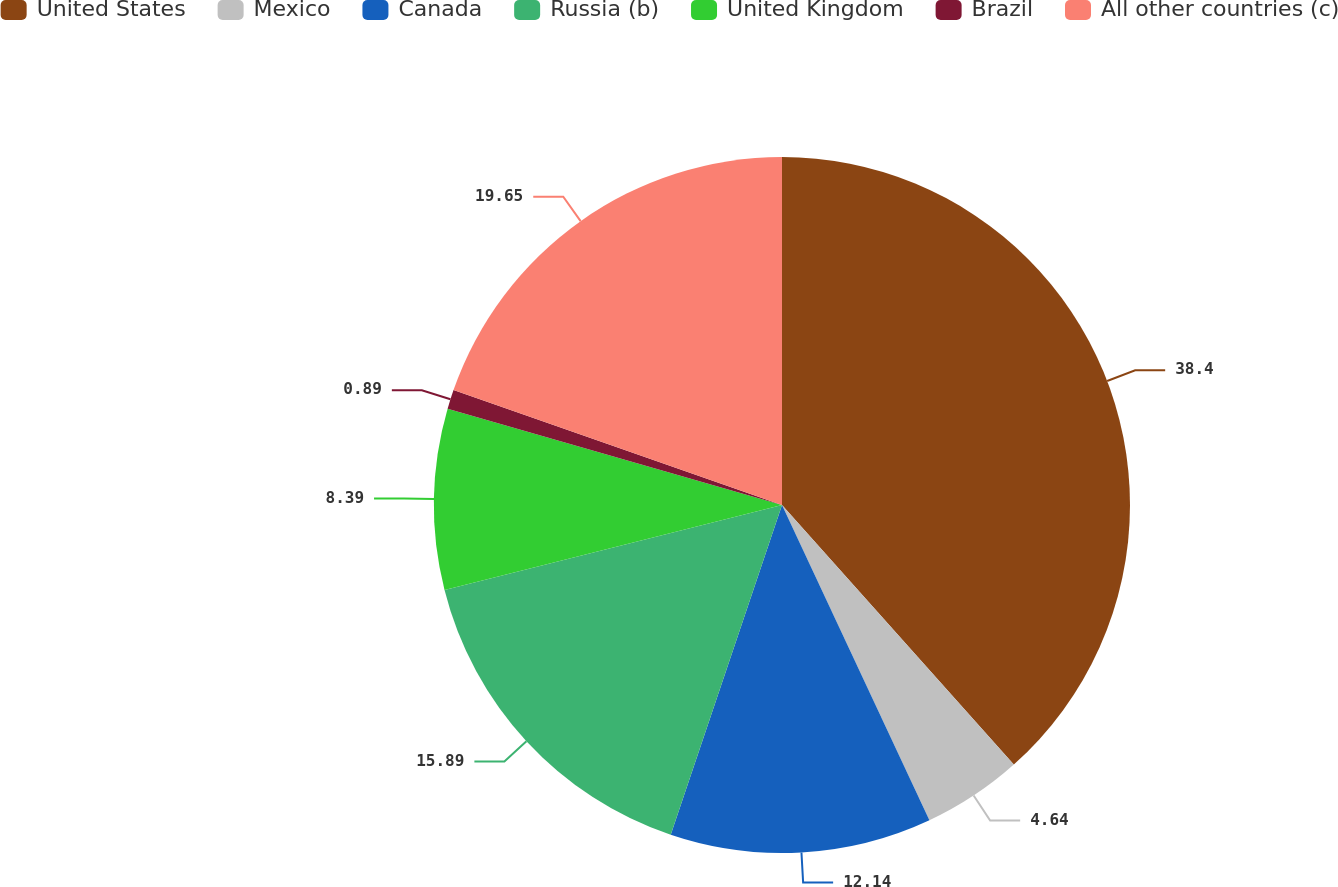<chart> <loc_0><loc_0><loc_500><loc_500><pie_chart><fcel>United States<fcel>Mexico<fcel>Canada<fcel>Russia (b)<fcel>United Kingdom<fcel>Brazil<fcel>All other countries (c)<nl><fcel>38.39%<fcel>4.64%<fcel>12.14%<fcel>15.89%<fcel>8.39%<fcel>0.89%<fcel>19.64%<nl></chart> 